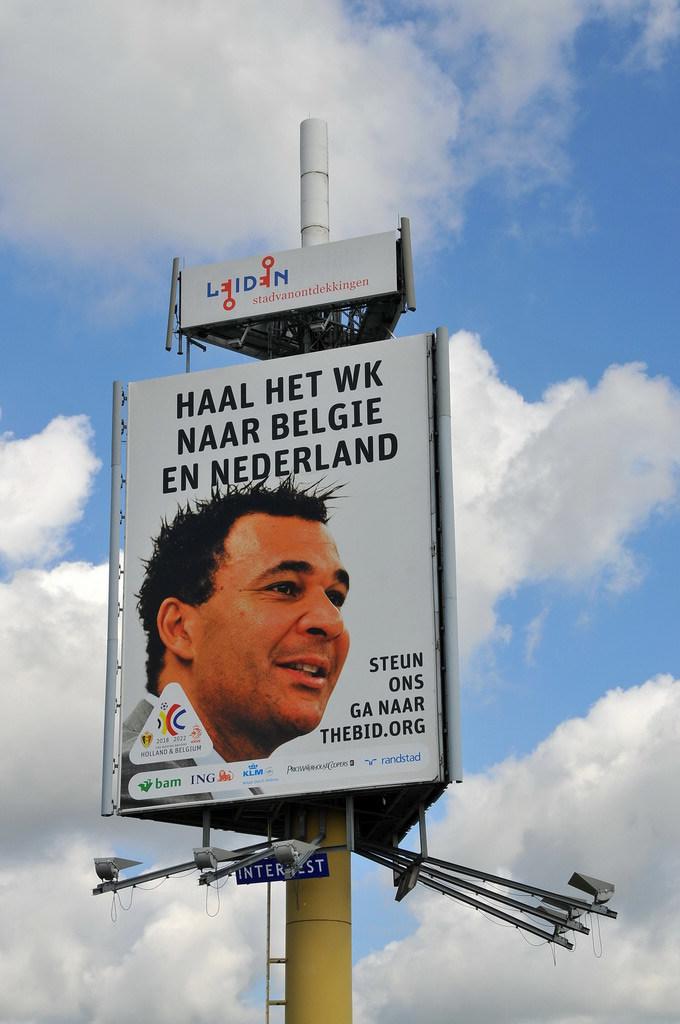What is the name of one of the companies on the bottom left?
Your answer should be compact. Ing. 